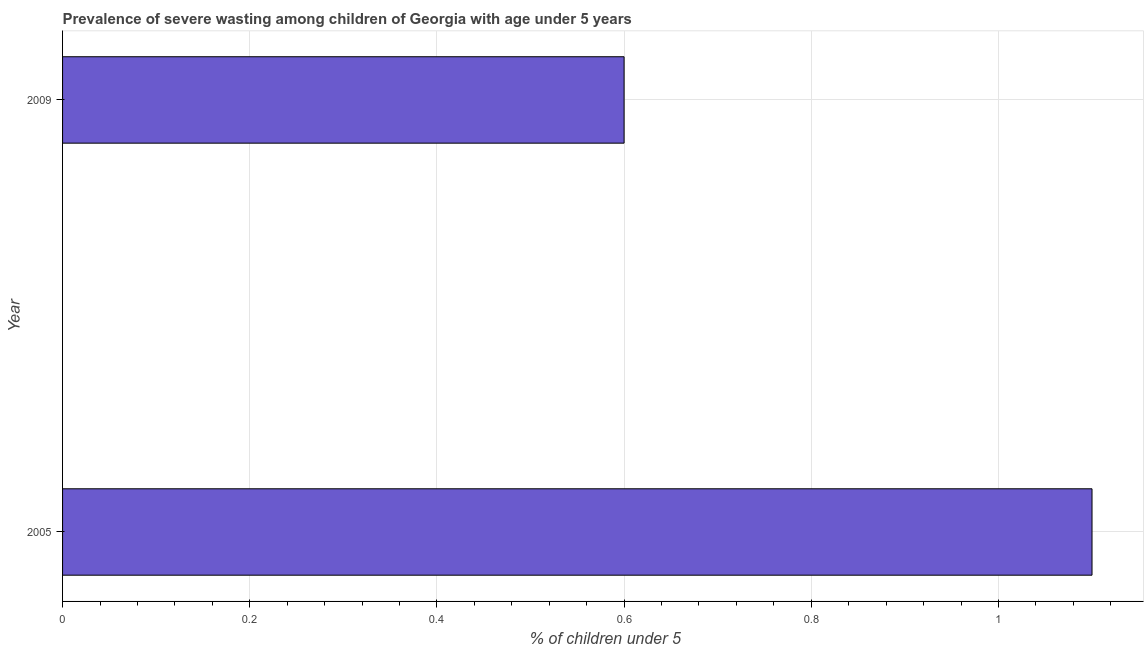Does the graph contain any zero values?
Make the answer very short. No. What is the title of the graph?
Keep it short and to the point. Prevalence of severe wasting among children of Georgia with age under 5 years. What is the label or title of the X-axis?
Your answer should be compact.  % of children under 5. What is the label or title of the Y-axis?
Offer a terse response. Year. What is the prevalence of severe wasting in 2005?
Ensure brevity in your answer.  1.1. Across all years, what is the maximum prevalence of severe wasting?
Offer a very short reply. 1.1. Across all years, what is the minimum prevalence of severe wasting?
Your answer should be compact. 0.6. In which year was the prevalence of severe wasting maximum?
Your response must be concise. 2005. In which year was the prevalence of severe wasting minimum?
Provide a short and direct response. 2009. What is the sum of the prevalence of severe wasting?
Ensure brevity in your answer.  1.7. What is the difference between the prevalence of severe wasting in 2005 and 2009?
Provide a short and direct response. 0.5. What is the median prevalence of severe wasting?
Give a very brief answer. 0.85. What is the ratio of the prevalence of severe wasting in 2005 to that in 2009?
Provide a short and direct response. 1.83. Is the prevalence of severe wasting in 2005 less than that in 2009?
Make the answer very short. No. How many bars are there?
Keep it short and to the point. 2. How many years are there in the graph?
Provide a short and direct response. 2. What is the difference between two consecutive major ticks on the X-axis?
Your response must be concise. 0.2. Are the values on the major ticks of X-axis written in scientific E-notation?
Provide a succinct answer. No. What is the  % of children under 5 of 2005?
Offer a terse response. 1.1. What is the  % of children under 5 of 2009?
Provide a succinct answer. 0.6. What is the ratio of the  % of children under 5 in 2005 to that in 2009?
Ensure brevity in your answer.  1.83. 